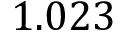<formula> <loc_0><loc_0><loc_500><loc_500>1 . 0 2 3</formula> 